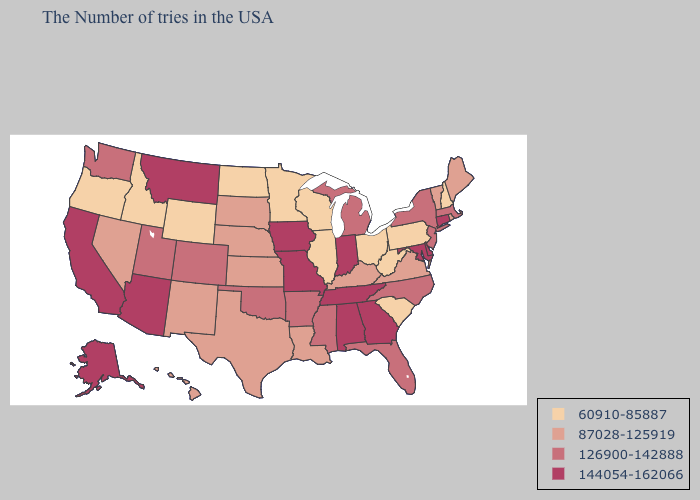Among the states that border Massachusetts , does New Hampshire have the lowest value?
Answer briefly. Yes. Which states have the lowest value in the West?
Keep it brief. Wyoming, Idaho, Oregon. What is the value of Indiana?
Keep it brief. 144054-162066. Does Illinois have a higher value than Georgia?
Keep it brief. No. What is the lowest value in the Northeast?
Write a very short answer. 60910-85887. Which states have the lowest value in the West?
Answer briefly. Wyoming, Idaho, Oregon. Does Montana have the highest value in the USA?
Write a very short answer. Yes. Name the states that have a value in the range 126900-142888?
Quick response, please. Massachusetts, New York, New Jersey, North Carolina, Florida, Michigan, Mississippi, Arkansas, Oklahoma, Colorado, Utah, Washington. Among the states that border North Dakota , does South Dakota have the highest value?
Concise answer only. No. Among the states that border South Dakota , does Wyoming have the highest value?
Give a very brief answer. No. Name the states that have a value in the range 87028-125919?
Answer briefly. Maine, Rhode Island, Vermont, Virginia, Kentucky, Louisiana, Kansas, Nebraska, Texas, South Dakota, New Mexico, Nevada, Hawaii. Does Alaska have the highest value in the USA?
Be succinct. Yes. Does Arizona have the highest value in the USA?
Keep it brief. Yes. What is the value of South Carolina?
Answer briefly. 60910-85887. Does Minnesota have the highest value in the USA?
Keep it brief. No. 